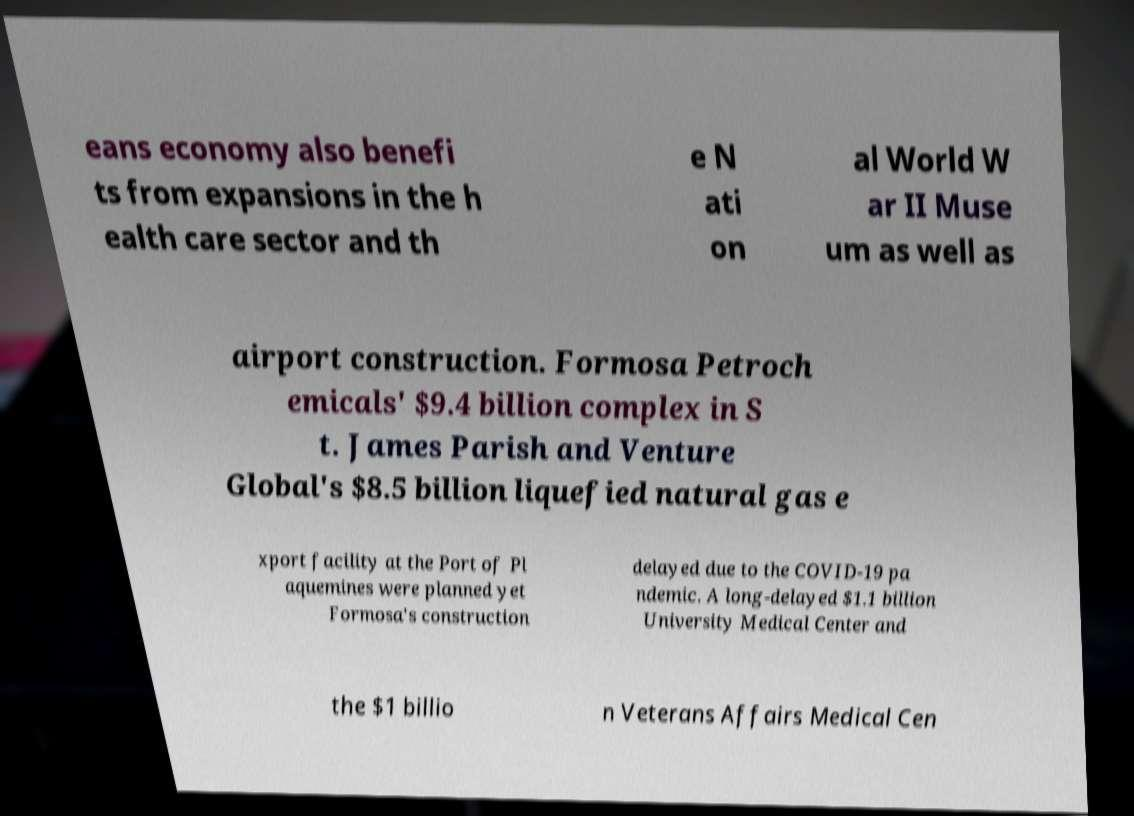Please read and relay the text visible in this image. What does it say? eans economy also benefi ts from expansions in the h ealth care sector and th e N ati on al World W ar II Muse um as well as airport construction. Formosa Petroch emicals' $9.4 billion complex in S t. James Parish and Venture Global's $8.5 billion liquefied natural gas e xport facility at the Port of Pl aquemines were planned yet Formosa's construction delayed due to the COVID-19 pa ndemic. A long-delayed $1.1 billion University Medical Center and the $1 billio n Veterans Affairs Medical Cen 